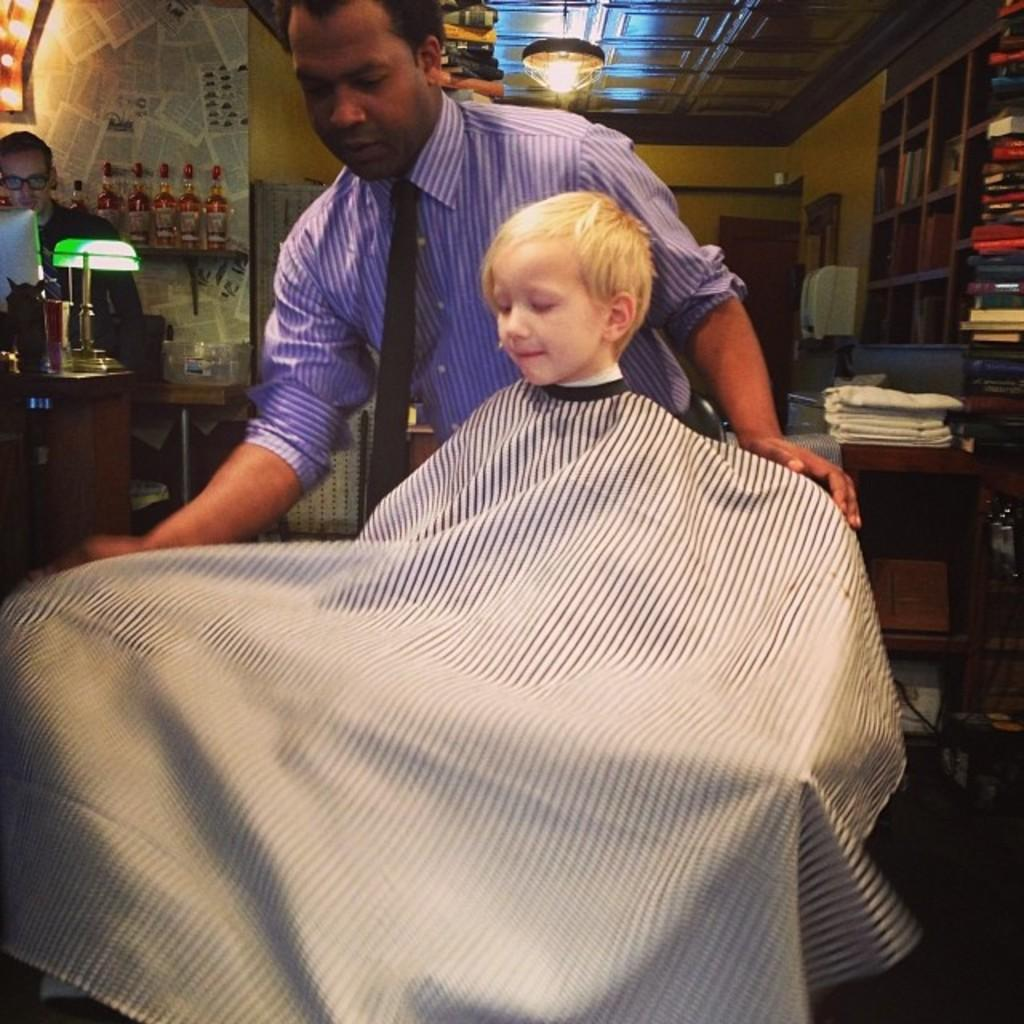How many people are in the image? There are two men and a kid in the image, making a total of three people. What is covering the table in the image? There is a tablecloth in the image. What items can be seen on the table? There are books, racks, bottles, and other objects in the image. Can you describe the lighting in the image? There is a lamp in the image, and there are lights in the background of the image. What is visible in the background of the image? There is a wall and a ceiling in the background of the image. What type of mint is growing on the wall in the image? There is no mint growing on the wall in the image. How many books are visible on the table in the image? The number of books visible on the table cannot be determined from the provided facts, as it only mentions that there are books on the table. 